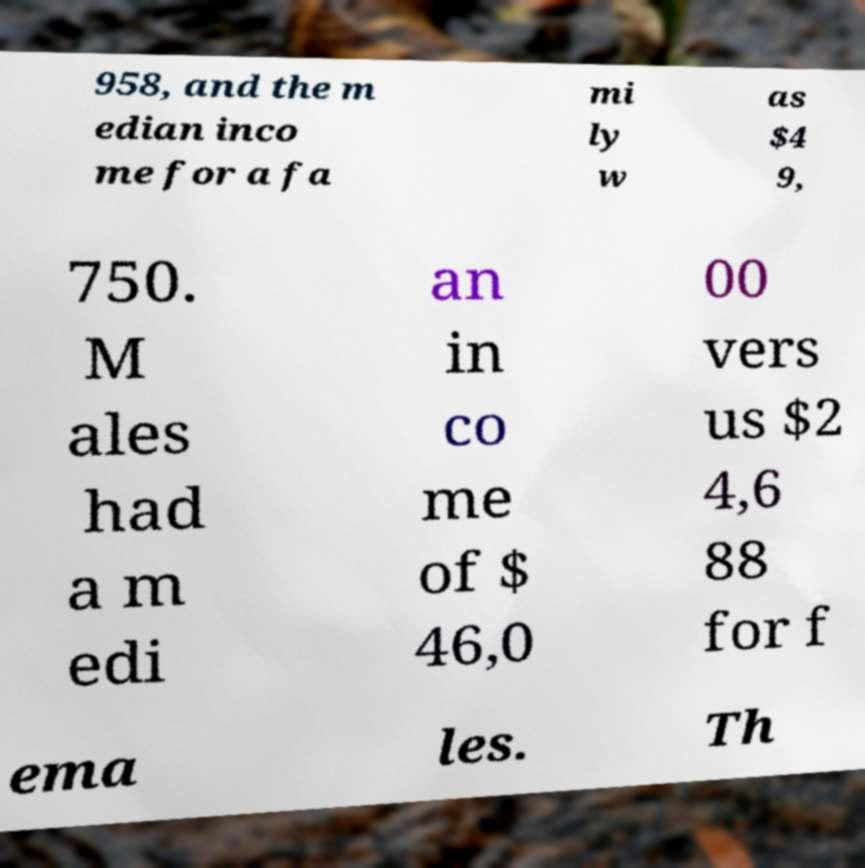For documentation purposes, I need the text within this image transcribed. Could you provide that? 958, and the m edian inco me for a fa mi ly w as $4 9, 750. M ales had a m edi an in co me of $ 46,0 00 vers us $2 4,6 88 for f ema les. Th 